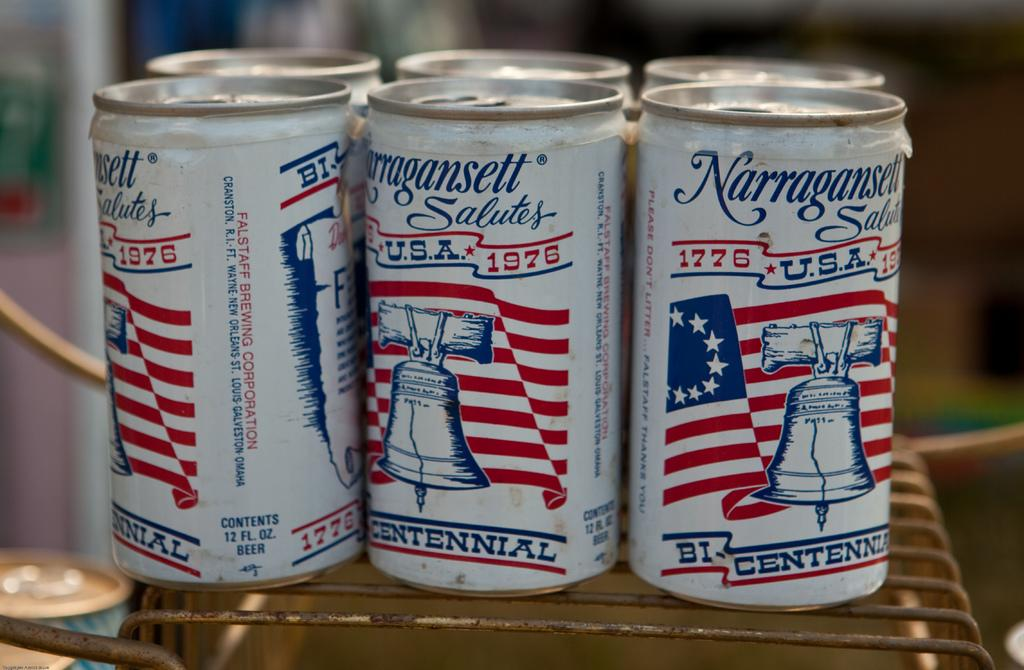<image>
Give a short and clear explanation of the subsequent image. Narragansett salute a US historical event with a picture of the liberty bell. 